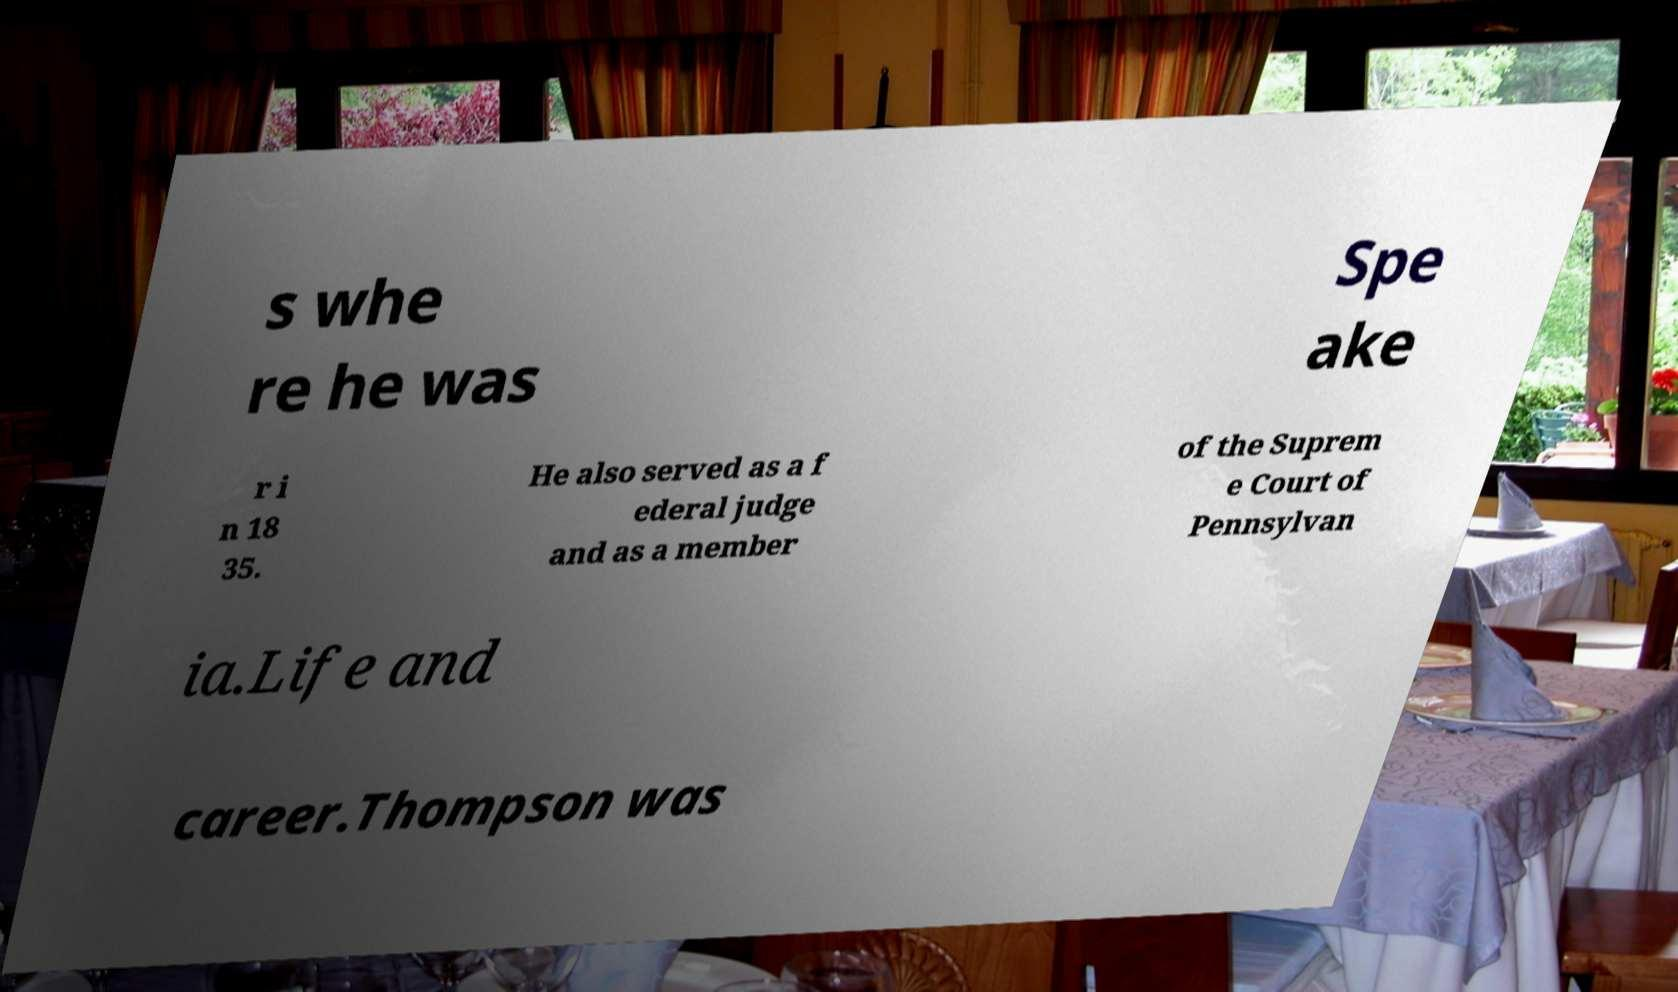Could you assist in decoding the text presented in this image and type it out clearly? s whe re he was Spe ake r i n 18 35. He also served as a f ederal judge and as a member of the Suprem e Court of Pennsylvan ia.Life and career.Thompson was 